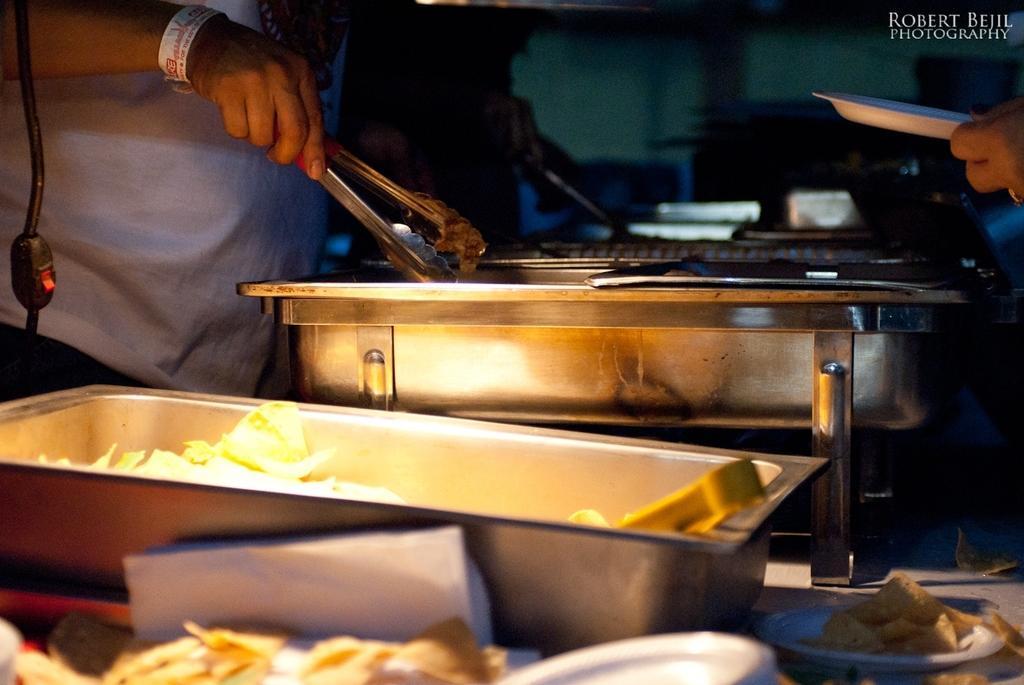How would you summarize this image in a sentence or two? In this image I can see a person holding some object, in front of the person I can see few bowls. I can also see the other person holding plate and the plate is in white color. 